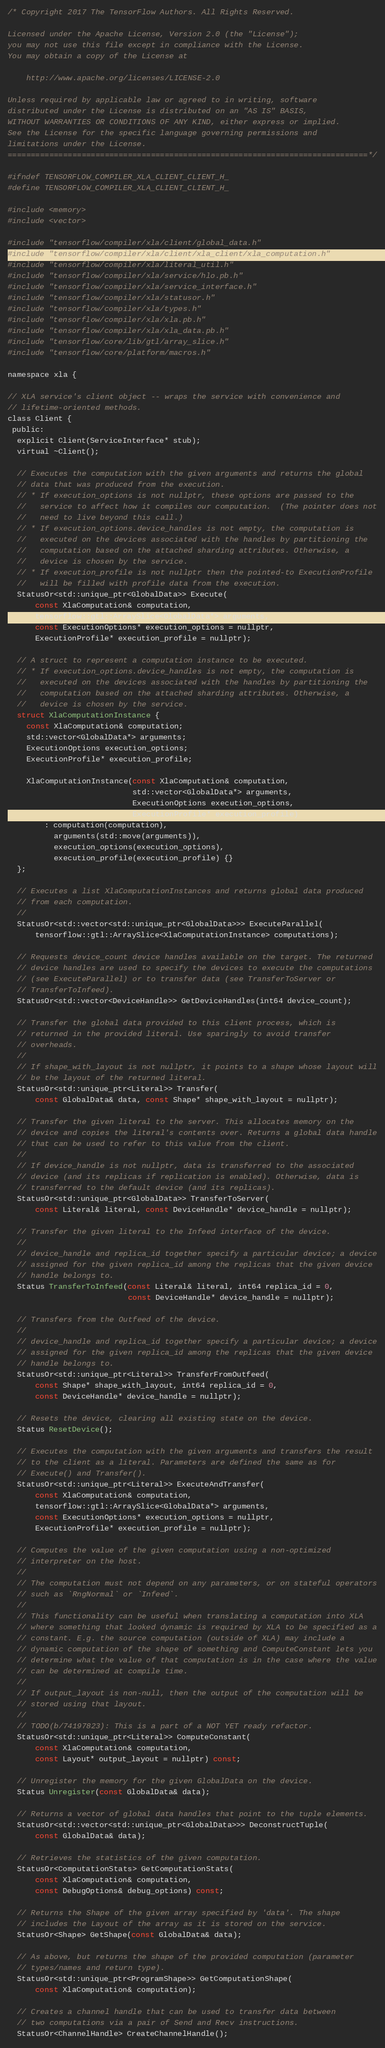<code> <loc_0><loc_0><loc_500><loc_500><_C_>/* Copyright 2017 The TensorFlow Authors. All Rights Reserved.

Licensed under the Apache License, Version 2.0 (the "License");
you may not use this file except in compliance with the License.
You may obtain a copy of the License at

    http://www.apache.org/licenses/LICENSE-2.0

Unless required by applicable law or agreed to in writing, software
distributed under the License is distributed on an "AS IS" BASIS,
WITHOUT WARRANTIES OR CONDITIONS OF ANY KIND, either express or implied.
See the License for the specific language governing permissions and
limitations under the License.
==============================================================================*/

#ifndef TENSORFLOW_COMPILER_XLA_CLIENT_CLIENT_H_
#define TENSORFLOW_COMPILER_XLA_CLIENT_CLIENT_H_

#include <memory>
#include <vector>

#include "tensorflow/compiler/xla/client/global_data.h"
#include "tensorflow/compiler/xla/client/xla_client/xla_computation.h"
#include "tensorflow/compiler/xla/literal_util.h"
#include "tensorflow/compiler/xla/service/hlo.pb.h"
#include "tensorflow/compiler/xla/service_interface.h"
#include "tensorflow/compiler/xla/statusor.h"
#include "tensorflow/compiler/xla/types.h"
#include "tensorflow/compiler/xla/xla.pb.h"
#include "tensorflow/compiler/xla/xla_data.pb.h"
#include "tensorflow/core/lib/gtl/array_slice.h"
#include "tensorflow/core/platform/macros.h"

namespace xla {

// XLA service's client object -- wraps the service with convenience and
// lifetime-oriented methods.
class Client {
 public:
  explicit Client(ServiceInterface* stub);
  virtual ~Client();

  // Executes the computation with the given arguments and returns the global
  // data that was produced from the execution.
  // * If execution_options is not nullptr, these options are passed to the
  //   service to affect how it compiles our computation.  (The pointer does not
  //   need to live beyond this call.)
  // * If execution_options.device_handles is not empty, the computation is
  //   executed on the devices associated with the handles by partitioning the
  //   computation based on the attached sharding attributes. Otherwise, a
  //   device is chosen by the service.
  // * If execution_profile is not nullptr then the pointed-to ExecutionProfile
  //   will be filled with profile data from the execution.
  StatusOr<std::unique_ptr<GlobalData>> Execute(
      const XlaComputation& computation,
      tensorflow::gtl::ArraySlice<GlobalData*> arguments,
      const ExecutionOptions* execution_options = nullptr,
      ExecutionProfile* execution_profile = nullptr);

  // A struct to represent a computation instance to be executed.
  // * If execution_options.device_handles is not empty, the computation is
  //   executed on the devices associated with the handles by partitioning the
  //   computation based on the attached sharding attributes. Otherwise, a
  //   device is chosen by the service.
  struct XlaComputationInstance {
    const XlaComputation& computation;
    std::vector<GlobalData*> arguments;
    ExecutionOptions execution_options;
    ExecutionProfile* execution_profile;

    XlaComputationInstance(const XlaComputation& computation,
                           std::vector<GlobalData*> arguments,
                           ExecutionOptions execution_options,
                           ExecutionProfile* execution_profile)
        : computation(computation),
          arguments(std::move(arguments)),
          execution_options(execution_options),
          execution_profile(execution_profile) {}
  };

  // Executes a list XlaComputationInstances and returns global data produced
  // from each computation.
  //
  StatusOr<std::vector<std::unique_ptr<GlobalData>>> ExecuteParallel(
      tensorflow::gtl::ArraySlice<XlaComputationInstance> computations);

  // Requests device_count device handles available on the target. The returned
  // device handles are used to specify the devices to execute the computations
  // (see ExecuteParallel) or to transfer data (see TransferToServer or
  // TransferToInfeed).
  StatusOr<std::vector<DeviceHandle>> GetDeviceHandles(int64 device_count);

  // Transfer the global data provided to this client process, which is
  // returned in the provided literal. Use sparingly to avoid transfer
  // overheads.
  //
  // If shape_with_layout is not nullptr, it points to a shape whose layout will
  // be the layout of the returned literal.
  StatusOr<std::unique_ptr<Literal>> Transfer(
      const GlobalData& data, const Shape* shape_with_layout = nullptr);

  // Transfer the given literal to the server. This allocates memory on the
  // device and copies the literal's contents over. Returns a global data handle
  // that can be used to refer to this value from the client.
  //
  // If device_handle is not nullptr, data is transferred to the associated
  // device (and its replicas if replication is enabled). Otherwise, data is
  // transferred to the default device (and its replicas).
  StatusOr<std::unique_ptr<GlobalData>> TransferToServer(
      const Literal& literal, const DeviceHandle* device_handle = nullptr);

  // Transfer the given literal to the Infeed interface of the device.
  //
  // device_handle and replica_id together specify a particular device; a device
  // assigned for the given replica_id among the replicas that the given device
  // handle belongs to.
  Status TransferToInfeed(const Literal& literal, int64 replica_id = 0,
                          const DeviceHandle* device_handle = nullptr);

  // Transfers from the Outfeed of the device.
  //
  // device_handle and replica_id together specify a particular device; a device
  // assigned for the given replica_id among the replicas that the given device
  // handle belongs to.
  StatusOr<std::unique_ptr<Literal>> TransferFromOutfeed(
      const Shape* shape_with_layout, int64 replica_id = 0,
      const DeviceHandle* device_handle = nullptr);

  // Resets the device, clearing all existing state on the device.
  Status ResetDevice();

  // Executes the computation with the given arguments and transfers the result
  // to the client as a literal. Parameters are defined the same as for
  // Execute() and Transfer().
  StatusOr<std::unique_ptr<Literal>> ExecuteAndTransfer(
      const XlaComputation& computation,
      tensorflow::gtl::ArraySlice<GlobalData*> arguments,
      const ExecutionOptions* execution_options = nullptr,
      ExecutionProfile* execution_profile = nullptr);

  // Computes the value of the given computation using a non-optimized
  // interpreter on the host.
  //
  // The computation must not depend on any parameters, or on stateful operators
  // such as `RngNormal` or `Infeed`.
  //
  // This functionality can be useful when translating a computation into XLA
  // where something that looked dynamic is required by XLA to be specified as a
  // constant. E.g. the source computation (outside of XLA) may include a
  // dynamic computation of the shape of something and ComputeConstant lets you
  // determine what the value of that computation is in the case where the value
  // can be determined at compile time.
  //
  // If output_layout is non-null, then the output of the computation will be
  // stored using that layout.
  //
  // TODO(b/74197823): This is a part of a NOT YET ready refactor.
  StatusOr<std::unique_ptr<Literal>> ComputeConstant(
      const XlaComputation& computation,
      const Layout* output_layout = nullptr) const;

  // Unregister the memory for the given GlobalData on the device.
  Status Unregister(const GlobalData& data);

  // Returns a vector of global data handles that point to the tuple elements.
  StatusOr<std::vector<std::unique_ptr<GlobalData>>> DeconstructTuple(
      const GlobalData& data);

  // Retrieves the statistics of the given computation.
  StatusOr<ComputationStats> GetComputationStats(
      const XlaComputation& computation,
      const DebugOptions& debug_options) const;

  // Returns the Shape of the given array specified by 'data'. The shape
  // includes the Layout of the array as it is stored on the service.
  StatusOr<Shape> GetShape(const GlobalData& data);

  // As above, but returns the shape of the provided computation (parameter
  // types/names and return type).
  StatusOr<std::unique_ptr<ProgramShape>> GetComputationShape(
      const XlaComputation& computation);

  // Creates a channel handle that can be used to transfer data between
  // two computations via a pair of Send and Recv instructions.
  StatusOr<ChannelHandle> CreateChannelHandle();
</code> 